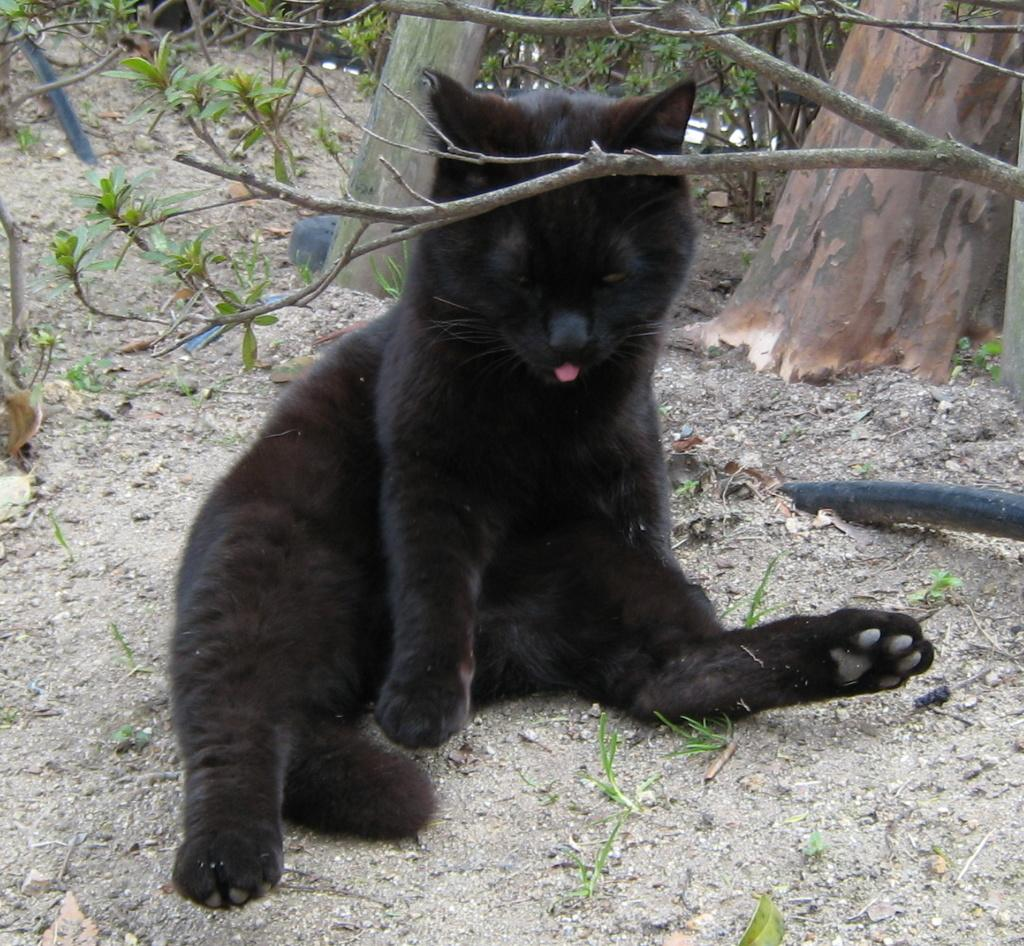What type of animal is in the image? There is a cat in the image. What color is the cat? The cat is black in color. What type of vegetation is visible in the image? There are trees in the image. What is on the ground in the image? There is grass on the ground in the image. Can you see a robin perched on the cat's back in the image? No, there is no robin present in the image. 